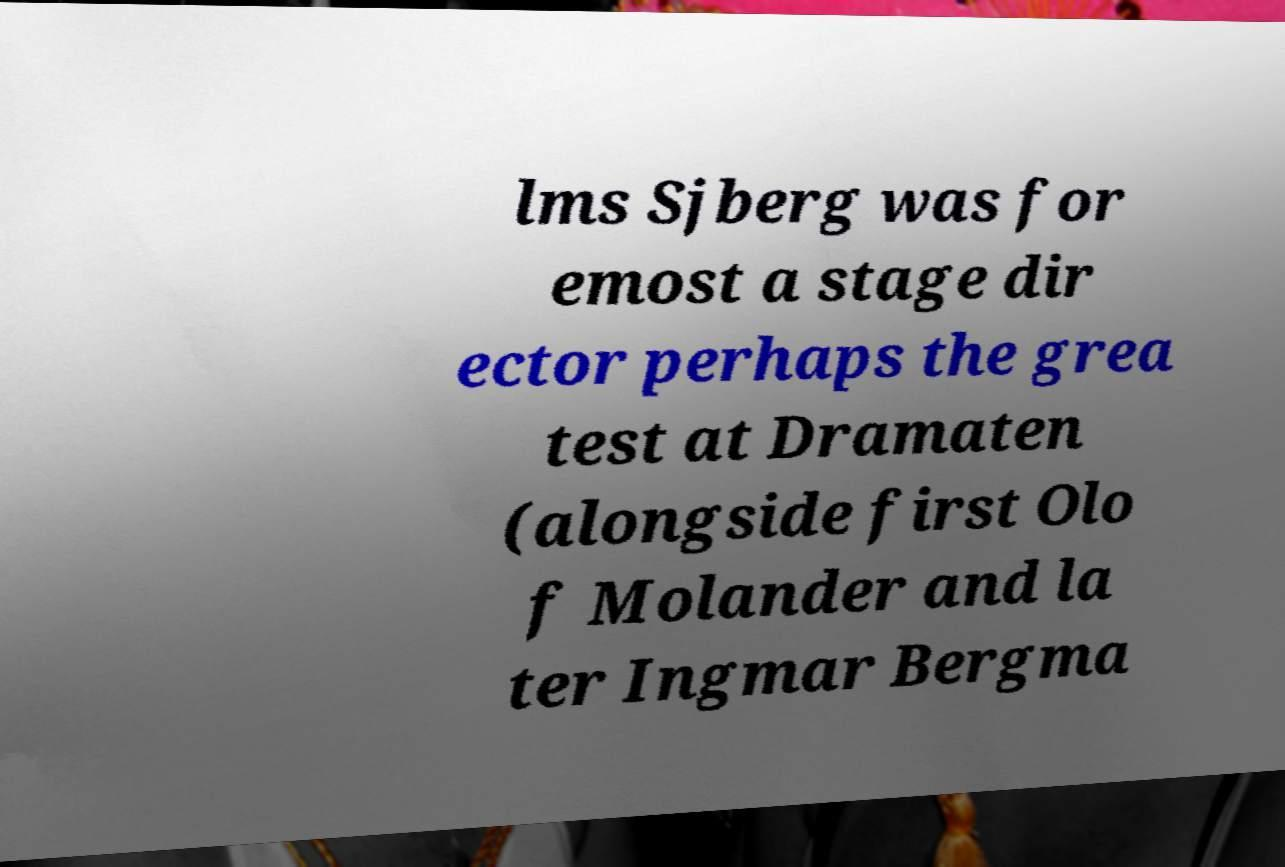What messages or text are displayed in this image? I need them in a readable, typed format. lms Sjberg was for emost a stage dir ector perhaps the grea test at Dramaten (alongside first Olo f Molander and la ter Ingmar Bergma 